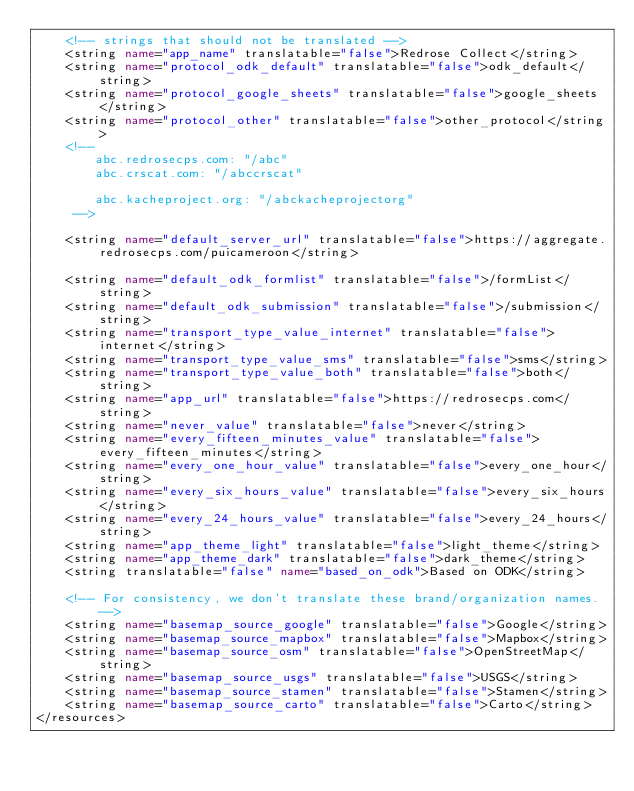Convert code to text. <code><loc_0><loc_0><loc_500><loc_500><_XML_>    <!-- strings that should not be translated -->
    <string name="app_name" translatable="false">Redrose Collect</string>
    <string name="protocol_odk_default" translatable="false">odk_default</string>
    <string name="protocol_google_sheets" translatable="false">google_sheets</string>
    <string name="protocol_other" translatable="false">other_protocol</string>
    <!--
        abc.redrosecps.com: "/abc"
        abc.crscat.com: "/abccrscat"

        abc.kacheproject.org: "/abckacheprojectorg"
     -->

    <string name="default_server_url" translatable="false">https://aggregate.redrosecps.com/puicameroon</string>

    <string name="default_odk_formlist" translatable="false">/formList</string>
    <string name="default_odk_submission" translatable="false">/submission</string>
    <string name="transport_type_value_internet" translatable="false">internet</string>
    <string name="transport_type_value_sms" translatable="false">sms</string>
    <string name="transport_type_value_both" translatable="false">both</string>
    <string name="app_url" translatable="false">https://redrosecps.com</string>
    <string name="never_value" translatable="false">never</string>
    <string name="every_fifteen_minutes_value" translatable="false">every_fifteen_minutes</string>
    <string name="every_one_hour_value" translatable="false">every_one_hour</string>
    <string name="every_six_hours_value" translatable="false">every_six_hours</string>
    <string name="every_24_hours_value" translatable="false">every_24_hours</string>
    <string name="app_theme_light" translatable="false">light_theme</string>
    <string name="app_theme_dark" translatable="false">dark_theme</string>
    <string translatable="false" name="based_on_odk">Based on ODK</string>

    <!-- For consistency, we don't translate these brand/organization names. -->
    <string name="basemap_source_google" translatable="false">Google</string>
    <string name="basemap_source_mapbox" translatable="false">Mapbox</string>
    <string name="basemap_source_osm" translatable="false">OpenStreetMap</string>
    <string name="basemap_source_usgs" translatable="false">USGS</string>
    <string name="basemap_source_stamen" translatable="false">Stamen</string>
    <string name="basemap_source_carto" translatable="false">Carto</string>
</resources>
</code> 